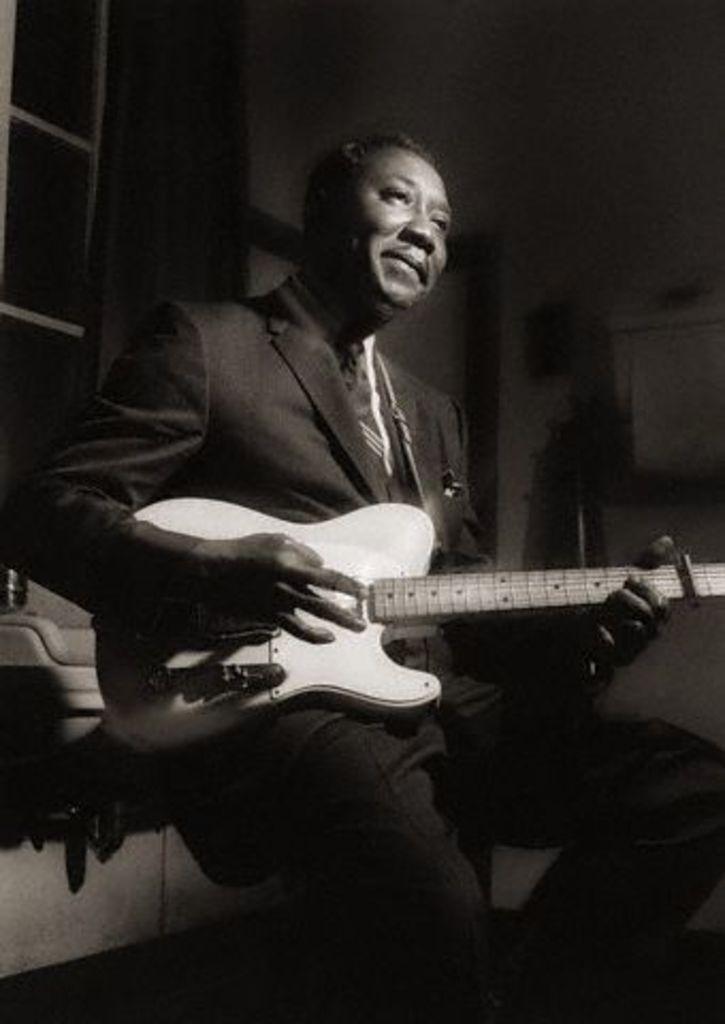Please provide a concise description of this image. In this picture we have a man who is wearing blazer which is black in color and wears black trouser, he holds guitar and he is playing it. He is sitting on some chair and it looks like house. 